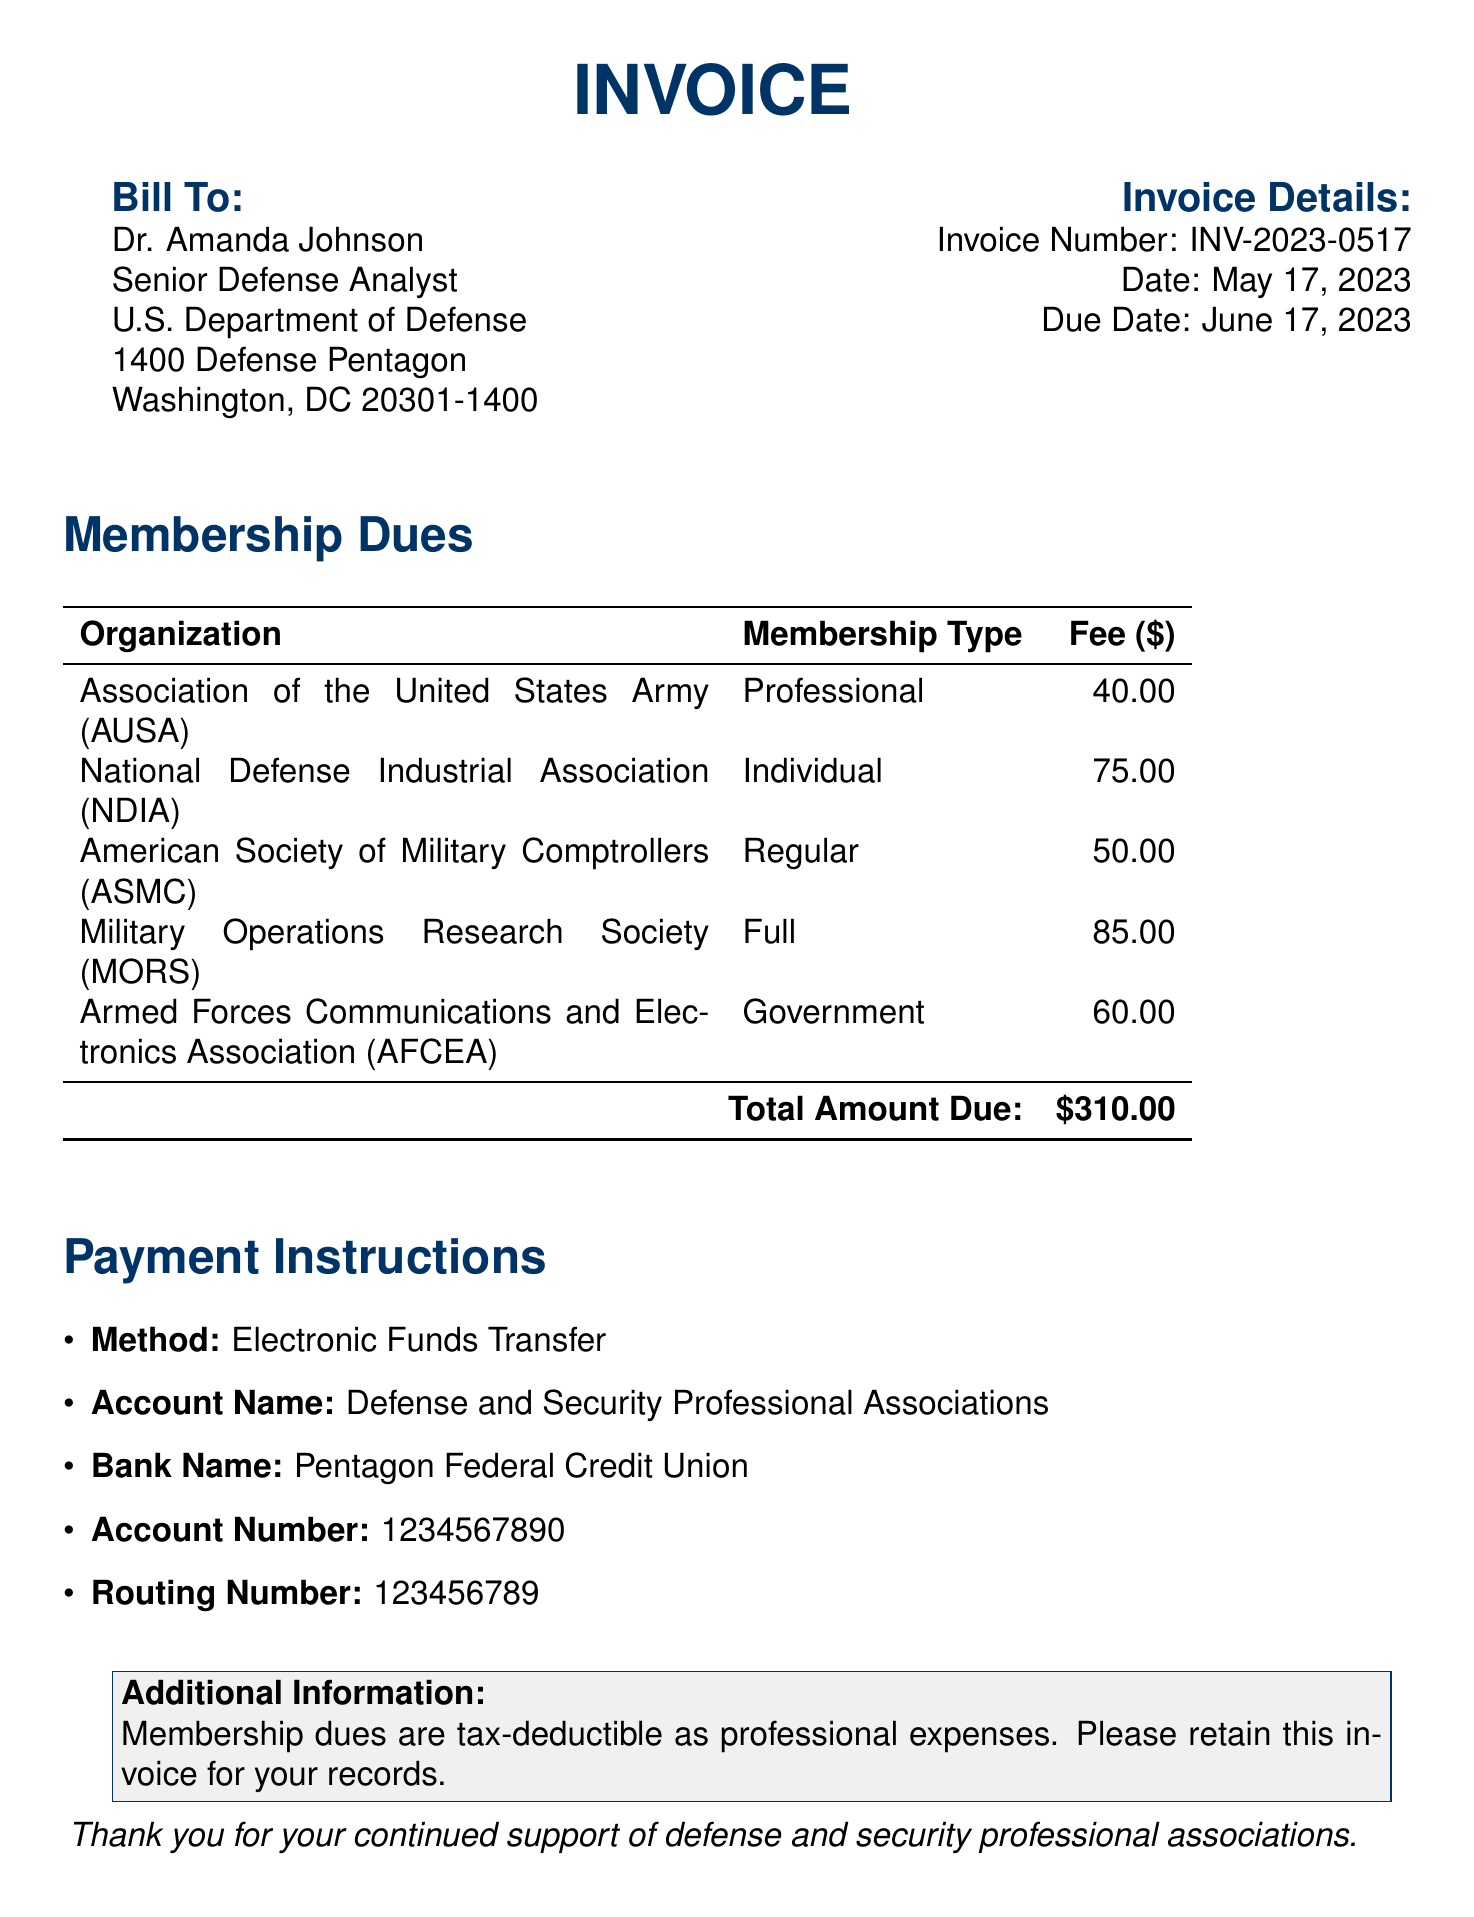What is the invoice number? The invoice number is a unique identifier for this invoice, listed in the document.
Answer: INV-2023-0517 What is the total amount due? The total amount due is the sum of all membership dues listed in the document.
Answer: $310.00 Who is the bill addressed to? This identifies the recipient of the invoice, specifically mentioned in the document.
Answer: Dr. Amanda Johnson Which organization has the highest membership fee? This requires comparing the fees of each organization listed in the document to determine which is the highest.
Answer: Military Operations Research Society (MORS) What payment method is specified for this invoice? This specifies the way the dues should be paid according to the payment instructions provided.
Answer: Electronic Funds Transfer How many organizations are listed for membership dues? This counts the number of organizations mentioned in the membership dues section of the document.
Answer: 5 What is the due date for the payment? This indicates the deadline by which the payment should be made as stated in the document.
Answer: June 17, 2023 What type of membership does AUSA provide? This specifies the membership type for the first organization listed in the document.
Answer: Professional 